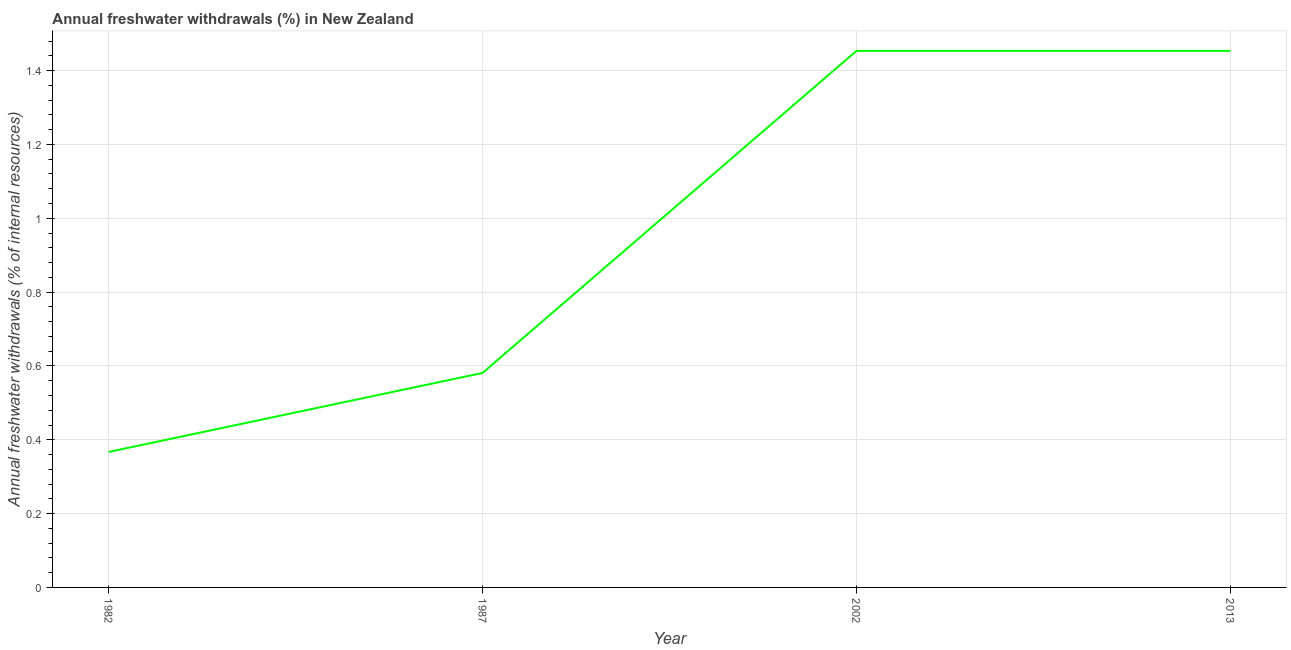What is the annual freshwater withdrawals in 2002?
Provide a succinct answer. 1.45. Across all years, what is the maximum annual freshwater withdrawals?
Provide a short and direct response. 1.45. Across all years, what is the minimum annual freshwater withdrawals?
Provide a short and direct response. 0.37. What is the sum of the annual freshwater withdrawals?
Keep it short and to the point. 3.86. What is the difference between the annual freshwater withdrawals in 2002 and 2013?
Provide a succinct answer. 0. What is the average annual freshwater withdrawals per year?
Provide a succinct answer. 0.96. What is the median annual freshwater withdrawals?
Your answer should be compact. 1.02. In how many years, is the annual freshwater withdrawals greater than 1.08 %?
Give a very brief answer. 2. What is the ratio of the annual freshwater withdrawals in 1982 to that in 2002?
Your answer should be compact. 0.25. Is the annual freshwater withdrawals in 1982 less than that in 2013?
Your answer should be compact. Yes. What is the difference between the highest and the second highest annual freshwater withdrawals?
Provide a succinct answer. 0. Is the sum of the annual freshwater withdrawals in 1982 and 1987 greater than the maximum annual freshwater withdrawals across all years?
Your answer should be very brief. No. What is the difference between the highest and the lowest annual freshwater withdrawals?
Give a very brief answer. 1.09. In how many years, is the annual freshwater withdrawals greater than the average annual freshwater withdrawals taken over all years?
Offer a very short reply. 2. Does the annual freshwater withdrawals monotonically increase over the years?
Offer a very short reply. No. How many lines are there?
Give a very brief answer. 1. How many years are there in the graph?
Keep it short and to the point. 4. What is the difference between two consecutive major ticks on the Y-axis?
Keep it short and to the point. 0.2. Are the values on the major ticks of Y-axis written in scientific E-notation?
Ensure brevity in your answer.  No. What is the title of the graph?
Ensure brevity in your answer.  Annual freshwater withdrawals (%) in New Zealand. What is the label or title of the X-axis?
Your response must be concise. Year. What is the label or title of the Y-axis?
Give a very brief answer. Annual freshwater withdrawals (% of internal resources). What is the Annual freshwater withdrawals (% of internal resources) in 1982?
Provide a short and direct response. 0.37. What is the Annual freshwater withdrawals (% of internal resources) of 1987?
Ensure brevity in your answer.  0.58. What is the Annual freshwater withdrawals (% of internal resources) of 2002?
Offer a terse response. 1.45. What is the Annual freshwater withdrawals (% of internal resources) of 2013?
Ensure brevity in your answer.  1.45. What is the difference between the Annual freshwater withdrawals (% of internal resources) in 1982 and 1987?
Your answer should be very brief. -0.21. What is the difference between the Annual freshwater withdrawals (% of internal resources) in 1982 and 2002?
Your response must be concise. -1.09. What is the difference between the Annual freshwater withdrawals (% of internal resources) in 1982 and 2013?
Keep it short and to the point. -1.09. What is the difference between the Annual freshwater withdrawals (% of internal resources) in 1987 and 2002?
Keep it short and to the point. -0.87. What is the difference between the Annual freshwater withdrawals (% of internal resources) in 1987 and 2013?
Your answer should be very brief. -0.87. What is the ratio of the Annual freshwater withdrawals (% of internal resources) in 1982 to that in 1987?
Keep it short and to the point. 0.63. What is the ratio of the Annual freshwater withdrawals (% of internal resources) in 1982 to that in 2002?
Offer a terse response. 0.25. What is the ratio of the Annual freshwater withdrawals (% of internal resources) in 1982 to that in 2013?
Make the answer very short. 0.25. What is the ratio of the Annual freshwater withdrawals (% of internal resources) in 1987 to that in 2002?
Provide a succinct answer. 0.4. 